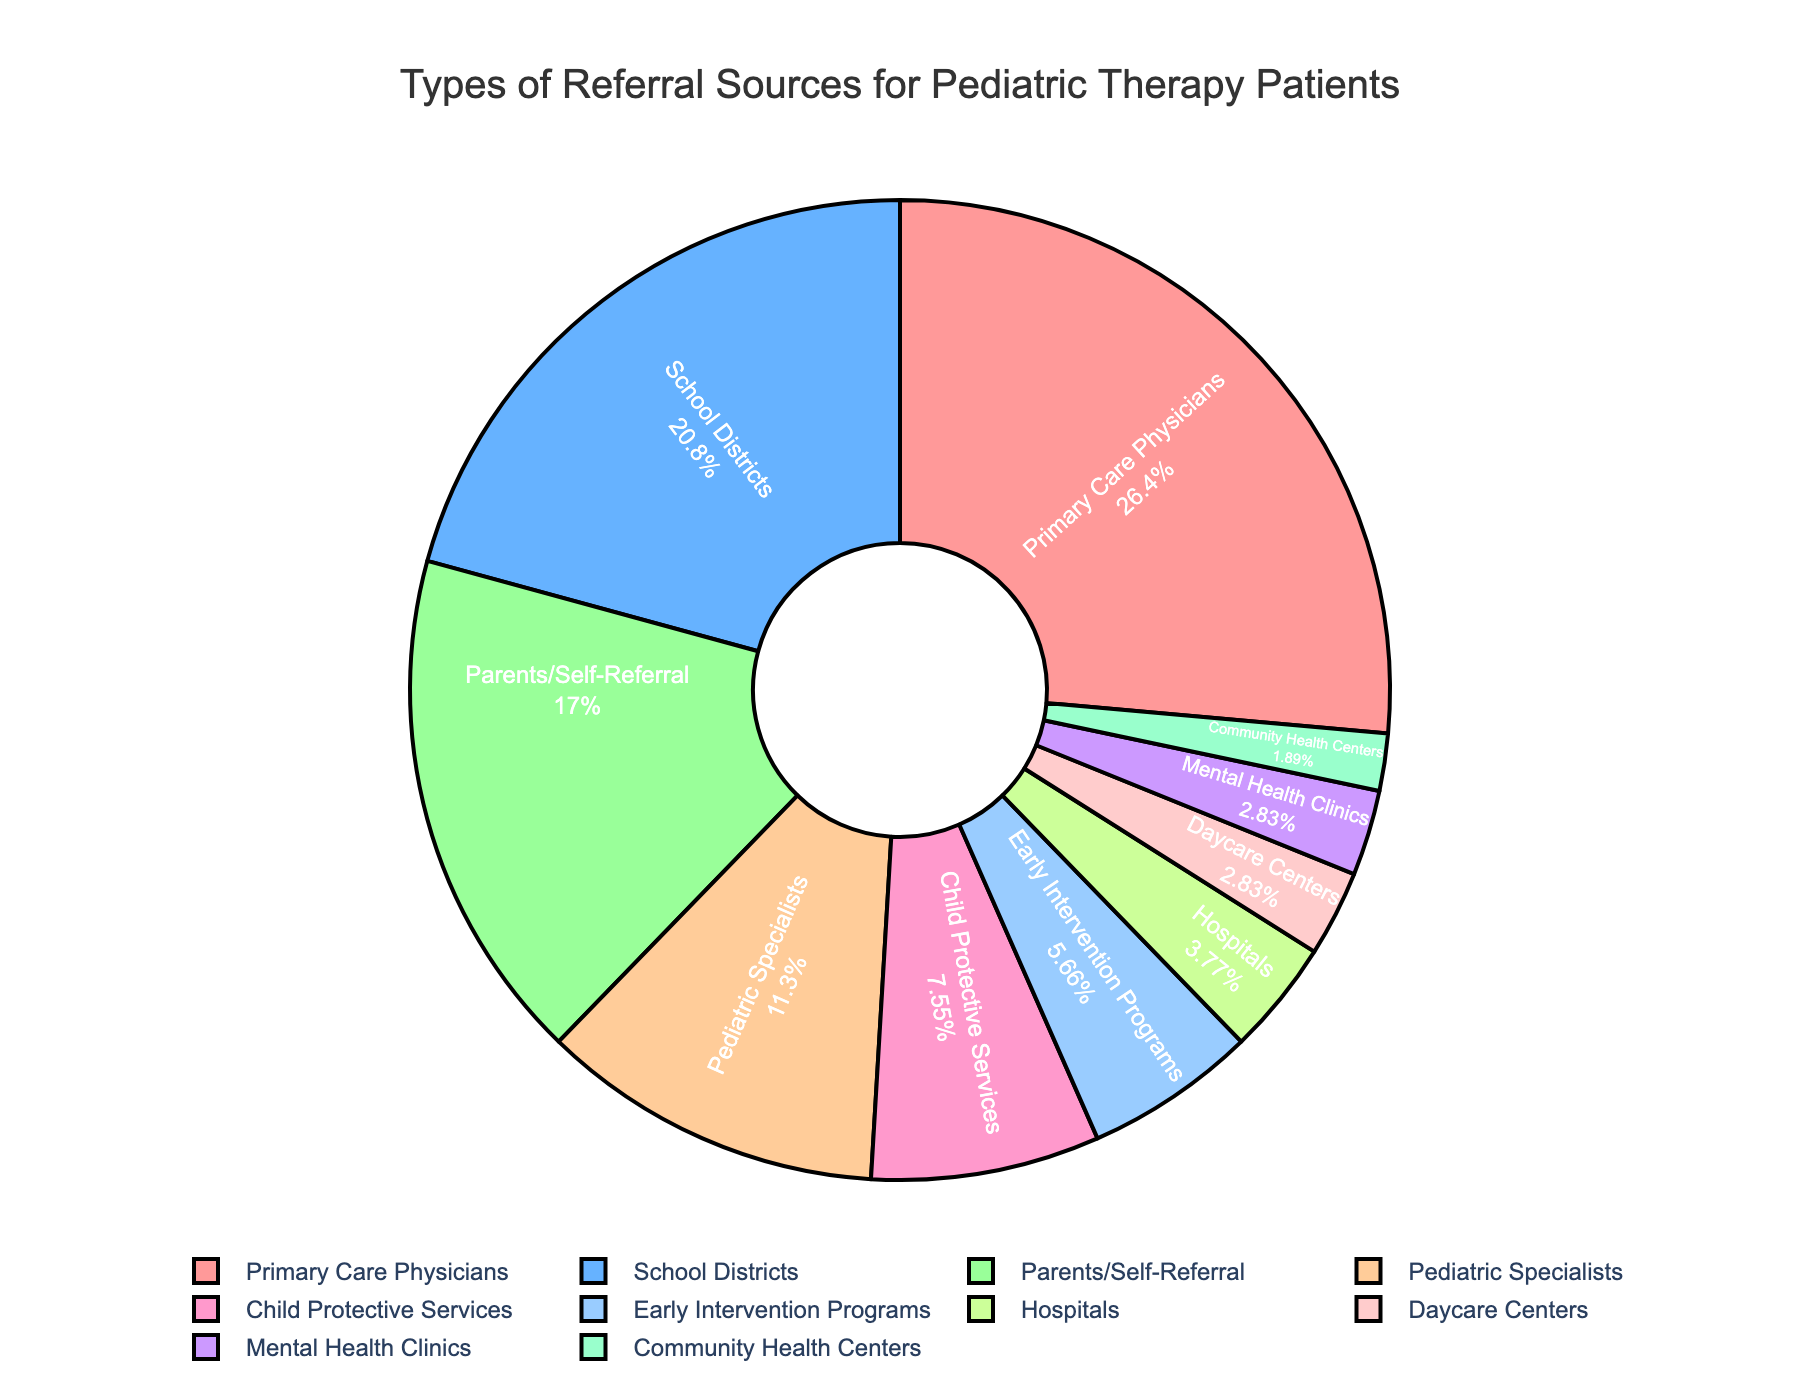What is the largest referral source? The largest segment representing the referral source is labeled "Primary Care Physicians" with 28%.
Answer: Primary Care Physicians What percentage of referrals come from hospitals and daycare centers combined? The pie chart segments for hospitals and daycare centers are labeled as 4% and 3% respectively. Adding these gives 4% + 3% = 7%.
Answer: 7% Which referral sources are equal in percentage? The pie chart shows "Mental Health Clinics" and "Daycare Centers" both labeled with 3%.
Answer: Mental Health Clinics and Daycare Centers Which referral source contributes more, Child Protective Services or Early Intervention Programs? The pie chart shows "Child Protective Services" with 8% and "Early Intervention Programs" with 6%. 8% is greater than 6%.
Answer: Child Protective Services What is the combined percentage of "Parents/Self-Referral" and "Pediatric Specialists"? "Parents/Self-Referral" is labeled with 18% and "Pediatric Specialists" with 12%. Adding these gives 18% + 12% = 30%.
Answer: 30% Which sectors represent less than 5% of the referrals each? The pie chart segments for Hospitals (4%), Daycare Centers (3%), Mental Health Clinics (3%), and Community Health Centers (2%) are all below 5%.
Answer: Hospitals, Daycare Centers, Mental Health Clinics, Community Health Centers How much more do Primary Care Physicians contribute compared to Pediatric Specialists? Primary Care Physicians contribute 28% and Pediatric Specialists contribute 12%. The difference is 28% - 12% = 16%.
Answer: 16% What fraction of referrals come from School Districts as compared to the total referrals from Primary Care Physicians and Parents/Self-Referral? School Districts contribute 22%. Primary Care Physicians contribute 28% and Parents/Self-Referral contribute 18% which summed is 46%. The fraction is 22/46. Simplifying this, both numerator and denominator can be divided by 2, giving 11/23 which approximately represents around 0.478 or 48%.
Answer: 48% Is the percentage from Early Intervention Programs higher or lower than Community Health Centers? The pie chart shows Early Intervention Programs with 6% and Community Health Centers with 2%. 6% is higher than 2%.
Answer: Higher 